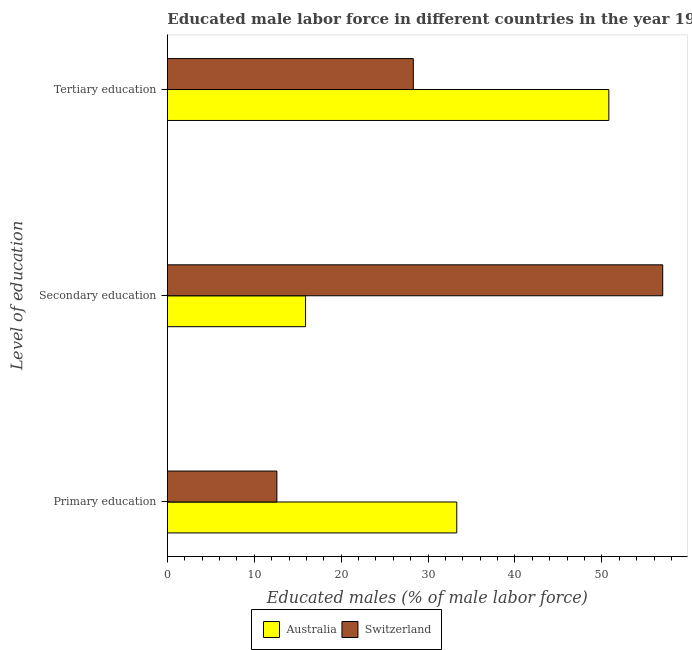How many different coloured bars are there?
Offer a very short reply. 2. Are the number of bars per tick equal to the number of legend labels?
Keep it short and to the point. Yes. How many bars are there on the 2nd tick from the bottom?
Keep it short and to the point. 2. What is the label of the 2nd group of bars from the top?
Give a very brief answer. Secondary education. What is the percentage of male labor force who received tertiary education in Switzerland?
Make the answer very short. 28.3. Across all countries, what is the maximum percentage of male labor force who received tertiary education?
Your response must be concise. 50.8. Across all countries, what is the minimum percentage of male labor force who received tertiary education?
Your answer should be compact. 28.3. In which country was the percentage of male labor force who received primary education maximum?
Keep it short and to the point. Australia. In which country was the percentage of male labor force who received primary education minimum?
Your answer should be very brief. Switzerland. What is the total percentage of male labor force who received tertiary education in the graph?
Ensure brevity in your answer.  79.1. What is the difference between the percentage of male labor force who received tertiary education in Australia and that in Switzerland?
Ensure brevity in your answer.  22.5. What is the difference between the percentage of male labor force who received tertiary education in Australia and the percentage of male labor force who received secondary education in Switzerland?
Offer a very short reply. -6.2. What is the average percentage of male labor force who received primary education per country?
Your answer should be compact. 22.95. What is the difference between the percentage of male labor force who received secondary education and percentage of male labor force who received primary education in Switzerland?
Offer a very short reply. 44.4. In how many countries, is the percentage of male labor force who received primary education greater than 14 %?
Provide a short and direct response. 1. What is the ratio of the percentage of male labor force who received secondary education in Switzerland to that in Australia?
Offer a terse response. 3.58. Is the percentage of male labor force who received tertiary education in Australia less than that in Switzerland?
Offer a terse response. No. What is the difference between the highest and the second highest percentage of male labor force who received tertiary education?
Your response must be concise. 22.5. What is the difference between the highest and the lowest percentage of male labor force who received tertiary education?
Ensure brevity in your answer.  22.5. What does the 1st bar from the top in Tertiary education represents?
Provide a short and direct response. Switzerland. Are all the bars in the graph horizontal?
Offer a very short reply. Yes. Are the values on the major ticks of X-axis written in scientific E-notation?
Offer a terse response. No. Does the graph contain any zero values?
Provide a succinct answer. No. How many legend labels are there?
Your answer should be very brief. 2. How are the legend labels stacked?
Make the answer very short. Horizontal. What is the title of the graph?
Offer a terse response. Educated male labor force in different countries in the year 1995. What is the label or title of the X-axis?
Your answer should be very brief. Educated males (% of male labor force). What is the label or title of the Y-axis?
Offer a very short reply. Level of education. What is the Educated males (% of male labor force) in Australia in Primary education?
Your answer should be compact. 33.3. What is the Educated males (% of male labor force) in Switzerland in Primary education?
Offer a very short reply. 12.6. What is the Educated males (% of male labor force) in Australia in Secondary education?
Your answer should be very brief. 15.9. What is the Educated males (% of male labor force) of Switzerland in Secondary education?
Give a very brief answer. 57. What is the Educated males (% of male labor force) in Australia in Tertiary education?
Make the answer very short. 50.8. What is the Educated males (% of male labor force) of Switzerland in Tertiary education?
Provide a succinct answer. 28.3. Across all Level of education, what is the maximum Educated males (% of male labor force) of Australia?
Offer a very short reply. 50.8. Across all Level of education, what is the maximum Educated males (% of male labor force) of Switzerland?
Ensure brevity in your answer.  57. Across all Level of education, what is the minimum Educated males (% of male labor force) in Australia?
Provide a short and direct response. 15.9. Across all Level of education, what is the minimum Educated males (% of male labor force) of Switzerland?
Offer a very short reply. 12.6. What is the total Educated males (% of male labor force) in Switzerland in the graph?
Your response must be concise. 97.9. What is the difference between the Educated males (% of male labor force) in Australia in Primary education and that in Secondary education?
Give a very brief answer. 17.4. What is the difference between the Educated males (% of male labor force) of Switzerland in Primary education and that in Secondary education?
Give a very brief answer. -44.4. What is the difference between the Educated males (% of male labor force) of Australia in Primary education and that in Tertiary education?
Keep it short and to the point. -17.5. What is the difference between the Educated males (% of male labor force) in Switzerland in Primary education and that in Tertiary education?
Provide a short and direct response. -15.7. What is the difference between the Educated males (% of male labor force) in Australia in Secondary education and that in Tertiary education?
Offer a terse response. -34.9. What is the difference between the Educated males (% of male labor force) of Switzerland in Secondary education and that in Tertiary education?
Keep it short and to the point. 28.7. What is the difference between the Educated males (% of male labor force) of Australia in Primary education and the Educated males (% of male labor force) of Switzerland in Secondary education?
Offer a terse response. -23.7. What is the difference between the Educated males (% of male labor force) of Australia in Primary education and the Educated males (% of male labor force) of Switzerland in Tertiary education?
Your answer should be compact. 5. What is the difference between the Educated males (% of male labor force) of Australia in Secondary education and the Educated males (% of male labor force) of Switzerland in Tertiary education?
Offer a very short reply. -12.4. What is the average Educated males (% of male labor force) in Australia per Level of education?
Provide a short and direct response. 33.33. What is the average Educated males (% of male labor force) in Switzerland per Level of education?
Ensure brevity in your answer.  32.63. What is the difference between the Educated males (% of male labor force) in Australia and Educated males (% of male labor force) in Switzerland in Primary education?
Your answer should be very brief. 20.7. What is the difference between the Educated males (% of male labor force) in Australia and Educated males (% of male labor force) in Switzerland in Secondary education?
Keep it short and to the point. -41.1. What is the difference between the Educated males (% of male labor force) of Australia and Educated males (% of male labor force) of Switzerland in Tertiary education?
Keep it short and to the point. 22.5. What is the ratio of the Educated males (% of male labor force) in Australia in Primary education to that in Secondary education?
Give a very brief answer. 2.09. What is the ratio of the Educated males (% of male labor force) of Switzerland in Primary education to that in Secondary education?
Offer a very short reply. 0.22. What is the ratio of the Educated males (% of male labor force) in Australia in Primary education to that in Tertiary education?
Offer a terse response. 0.66. What is the ratio of the Educated males (% of male labor force) of Switzerland in Primary education to that in Tertiary education?
Your response must be concise. 0.45. What is the ratio of the Educated males (% of male labor force) in Australia in Secondary education to that in Tertiary education?
Your response must be concise. 0.31. What is the ratio of the Educated males (% of male labor force) in Switzerland in Secondary education to that in Tertiary education?
Your answer should be compact. 2.01. What is the difference between the highest and the second highest Educated males (% of male labor force) in Switzerland?
Offer a very short reply. 28.7. What is the difference between the highest and the lowest Educated males (% of male labor force) in Australia?
Your answer should be very brief. 34.9. What is the difference between the highest and the lowest Educated males (% of male labor force) in Switzerland?
Make the answer very short. 44.4. 